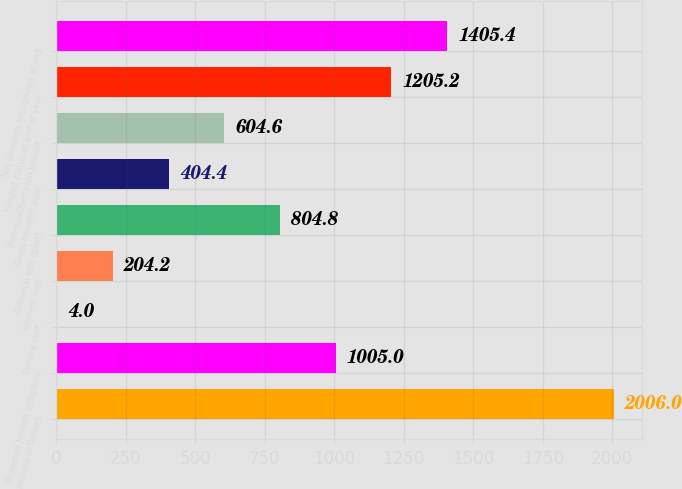Convert chart. <chart><loc_0><loc_0><loc_500><loc_500><bar_chart><fcel>Millions of Dollars<fcel>Projected benefit obligation<fcel>Service cost<fcel>Interest cost<fcel>Actuarial loss (gain)<fcel>Gross benefits paid<fcel>Non-qualified plan benefit<fcel>Funded status at end of year<fcel>Net amounts recognized at end<nl><fcel>2006<fcel>1005<fcel>4<fcel>204.2<fcel>804.8<fcel>404.4<fcel>604.6<fcel>1205.2<fcel>1405.4<nl></chart> 